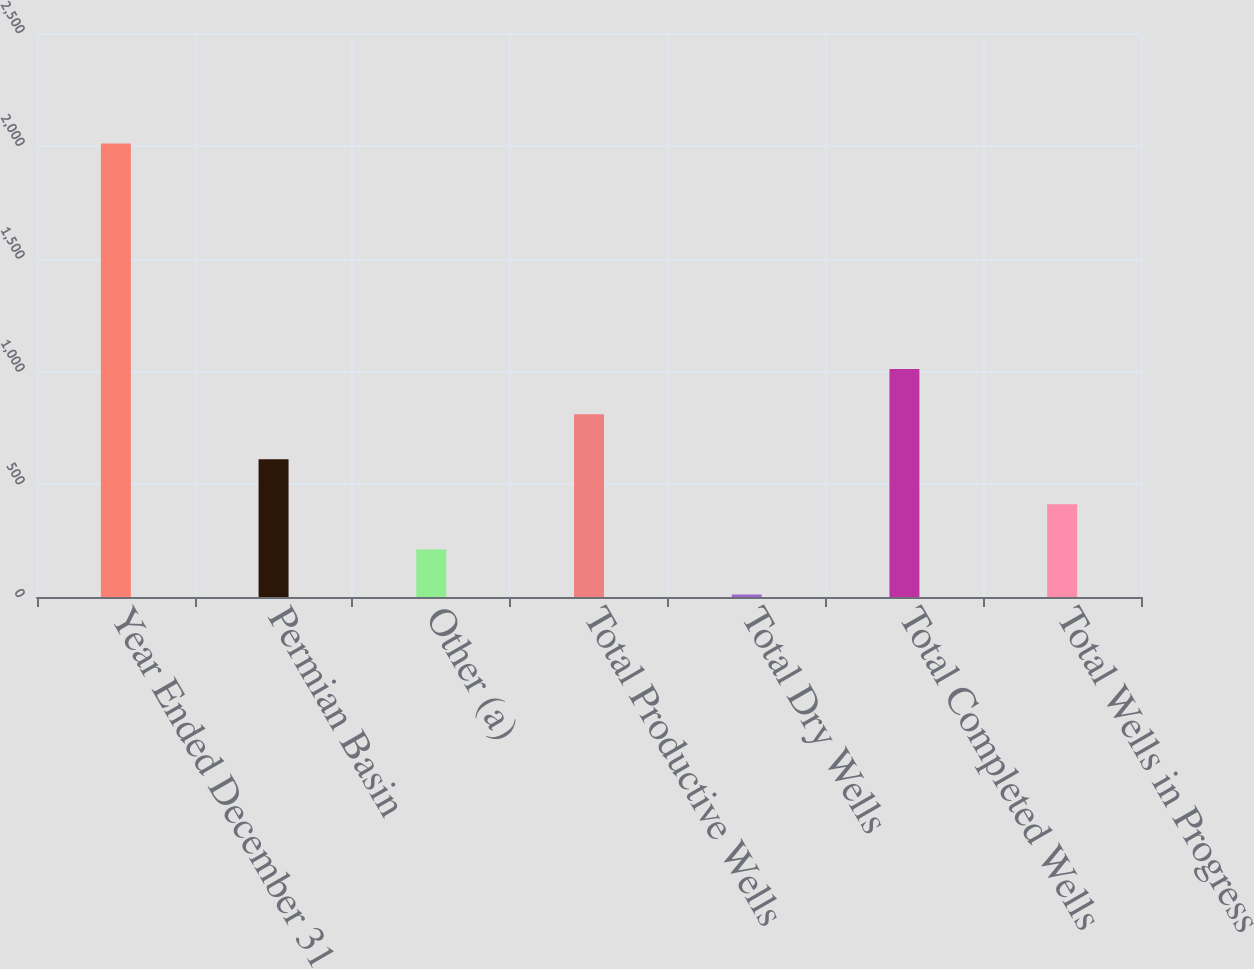Convert chart. <chart><loc_0><loc_0><loc_500><loc_500><bar_chart><fcel>Year Ended December 31<fcel>Permian Basin<fcel>Other (a)<fcel>Total Productive Wells<fcel>Total Dry Wells<fcel>Total Completed Wells<fcel>Total Wells in Progress<nl><fcel>2010<fcel>610.7<fcel>210.9<fcel>810.6<fcel>11<fcel>1010.5<fcel>410.8<nl></chart> 